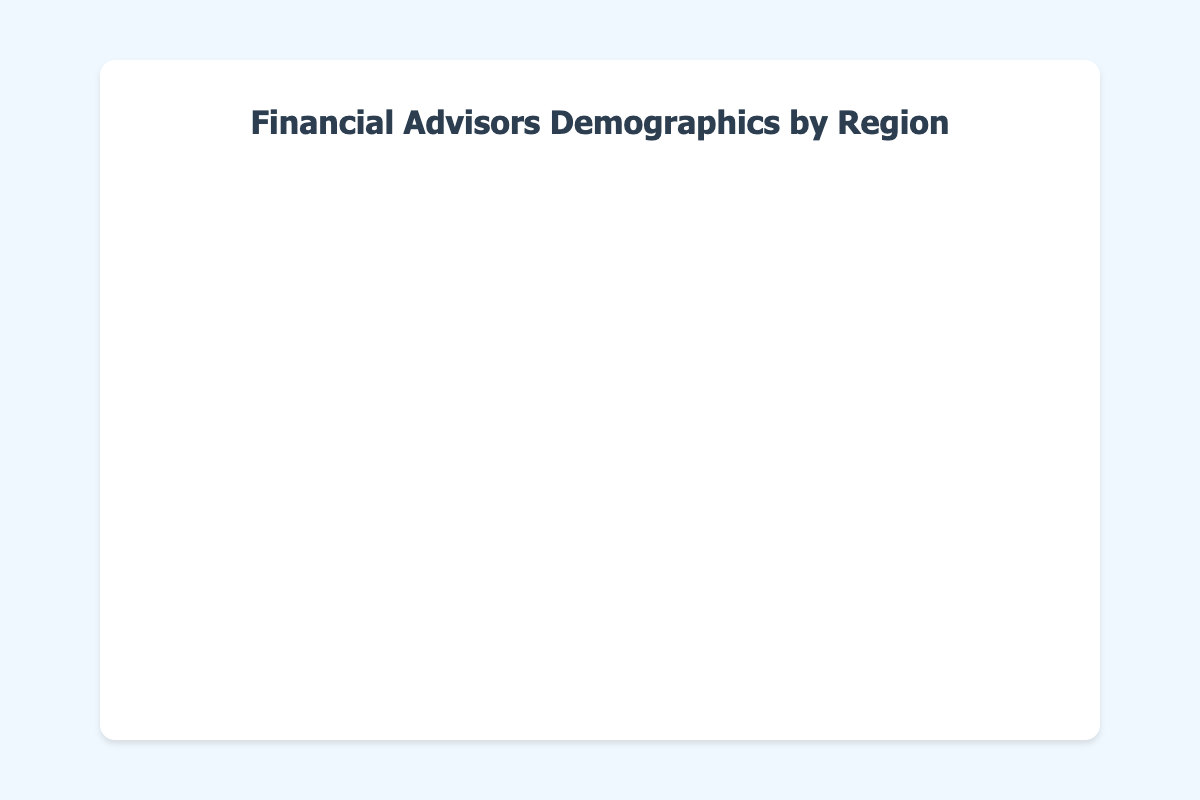What is the title of the bubble chart? The title is usually displayed at the top of the chart. In this bubble chart, look for the text indicating the title.
Answer: Financial Advisors Demographics by Region What does the x-axis represent? The x-axis label provides information about what is being plotted on this axis. Check for the label text along the x-axis.
Answer: Average Age Which region has the largest average client portfolio size? Examine the y-axis for the highest bubble position and check the corresponding region label for that bubble.
Answer: North America How many regions are represented in the chart? Count the number of distinct bubbles, each representing a different region.
Answer: 5 Which region has the oldest average age for financial advisors? Look at the bubbles placed furthest towards the right on the x-axis, where the average age is higher, and identify the region label.
Answer: North America What is the average age and average client portfolio size for Europe? Locate the bubble for Europe and note its x and y values.
Answer: Average Age: 42, Portfolio Size: $1,200,000 Is the average client portfolio size in Latin America greater than in the Middle East & Africa? Compare the y-axis positions of the bubbles for Latin America and Middle East & Africa.
Answer: No Which region has the lowest number of financial advisors? The bubble size indicates the number of advisors. Identify the smallest bubble and read its region label.
Answer: Middle East & Africa How does the average client portfolio size in Asia-Pacific compare to that in Europe? Compare the positions of the bubbles for Asia-Pacific and Europe along the y-axis.
Answer: Asia-Pacific has a smaller average client portfolio size What is the combined number of financial advisors in North America and Europe? Sum the advisor counts for North America and Europe by comparing bubble sizes and converting to actual values. North America has 8500 advisors (radius 85) and Europe has 6000 advisors (radius 60). Combine them: 8500 + 6000 = 14500.
Answer: 14500 